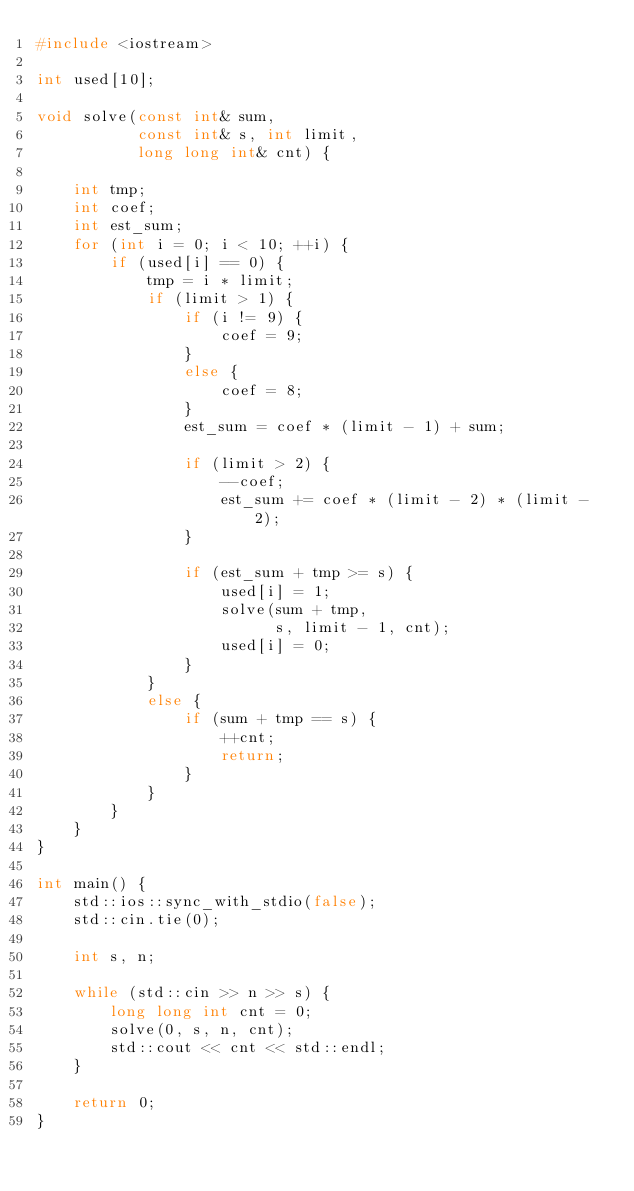<code> <loc_0><loc_0><loc_500><loc_500><_C++_>#include <iostream>

int used[10];

void solve(const int& sum,
           const int& s, int limit,
           long long int& cnt) {

    int tmp;
    int coef;
    int est_sum;
    for (int i = 0; i < 10; ++i) {
        if (used[i] == 0) {
            tmp = i * limit;
            if (limit > 1) {
                if (i != 9) {
                    coef = 9;
                }
                else {
                    coef = 8;
                }
                est_sum = coef * (limit - 1) + sum;

                if (limit > 2) {
                    --coef;
                    est_sum += coef * (limit - 2) * (limit - 2);
                }

                if (est_sum + tmp >= s) {
                    used[i] = 1;
                    solve(sum + tmp,
                          s, limit - 1, cnt);
                    used[i] = 0;
                }
            }
            else {
                if (sum + tmp == s) {
                    ++cnt;
                    return;
                }
            }
        }
    }
}

int main() {
    std::ios::sync_with_stdio(false);
    std::cin.tie(0);

    int s, n;

    while (std::cin >> n >> s) {
        long long int cnt = 0;
        solve(0, s, n, cnt);
        std::cout << cnt << std::endl;
    }

    return 0;
}</code> 